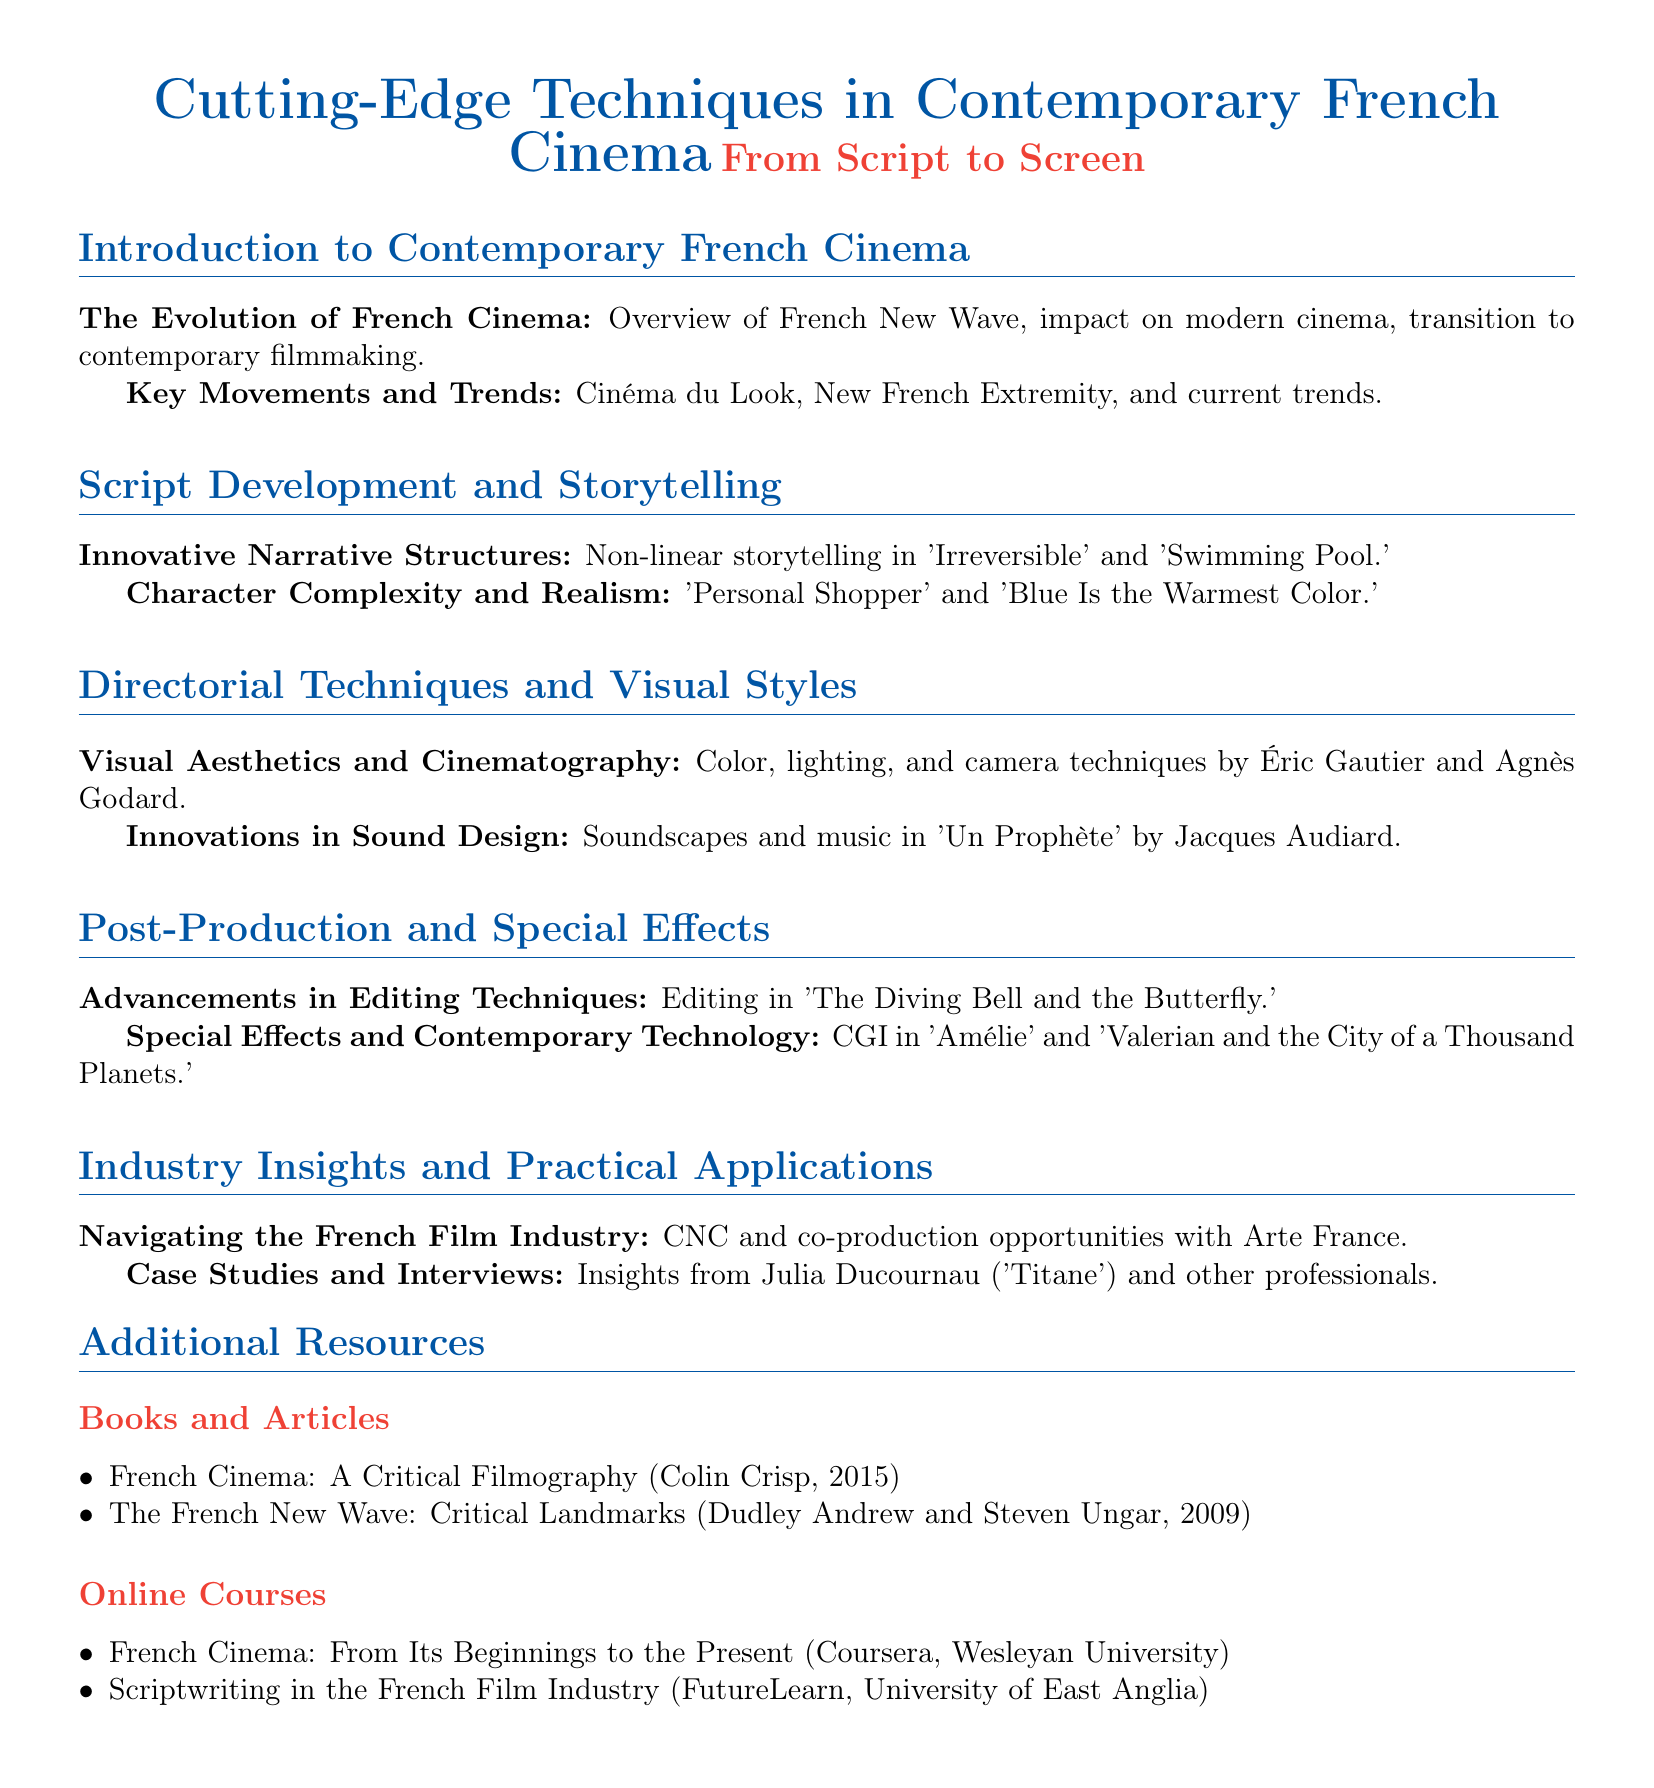What is the title of the syllabus? The title of the syllabus is "Cutting-Edge Techniques in Contemporary French Cinema."
Answer: Cutting-Edge Techniques in Contemporary French Cinema Who is the director associated with "Un Prophète"? The document mentions Jacques Audiard as the director of "Un Prophète."
Answer: Jacques Audiard What are two key movements discussed in the syllabus? The syllabus lists "Cinéma du Look" and "New French Extremity" as key movements.
Answer: Cinéma du Look, New French Extremity What is one innovative narrative structure mentioned? The syllabus refers to non-linear storytelling in "Irreversible" and "Swimming Pool."
Answer: Non-linear storytelling Name one resource listed in the additional resources section. The document lists "French Cinema: A Critical Filmography" as one resource.
Answer: French Cinema: A Critical Filmography What is one of the online courses offered according to the document? The syllabus includes "Scriptwriting in the French Film Industry" as an online course.
Answer: Scriptwriting in the French Film Industry Who is a case study mentioned in the syllabus? The document mentions Julia Ducournau as a case study and professional in the film industry.
Answer: Julia Ducournau Which film is associated with advancements in editing techniques? The syllabus indicates "The Diving Bell and the Butterfly" as the film connected to advancements in editing techniques.
Answer: The Diving Bell and the Butterfly What type of storytelling is highlighted in "Personal Shopper"? The syllabus describes character complexity and realism as highlighted in "Personal Shopper."
Answer: Character complexity and realism 